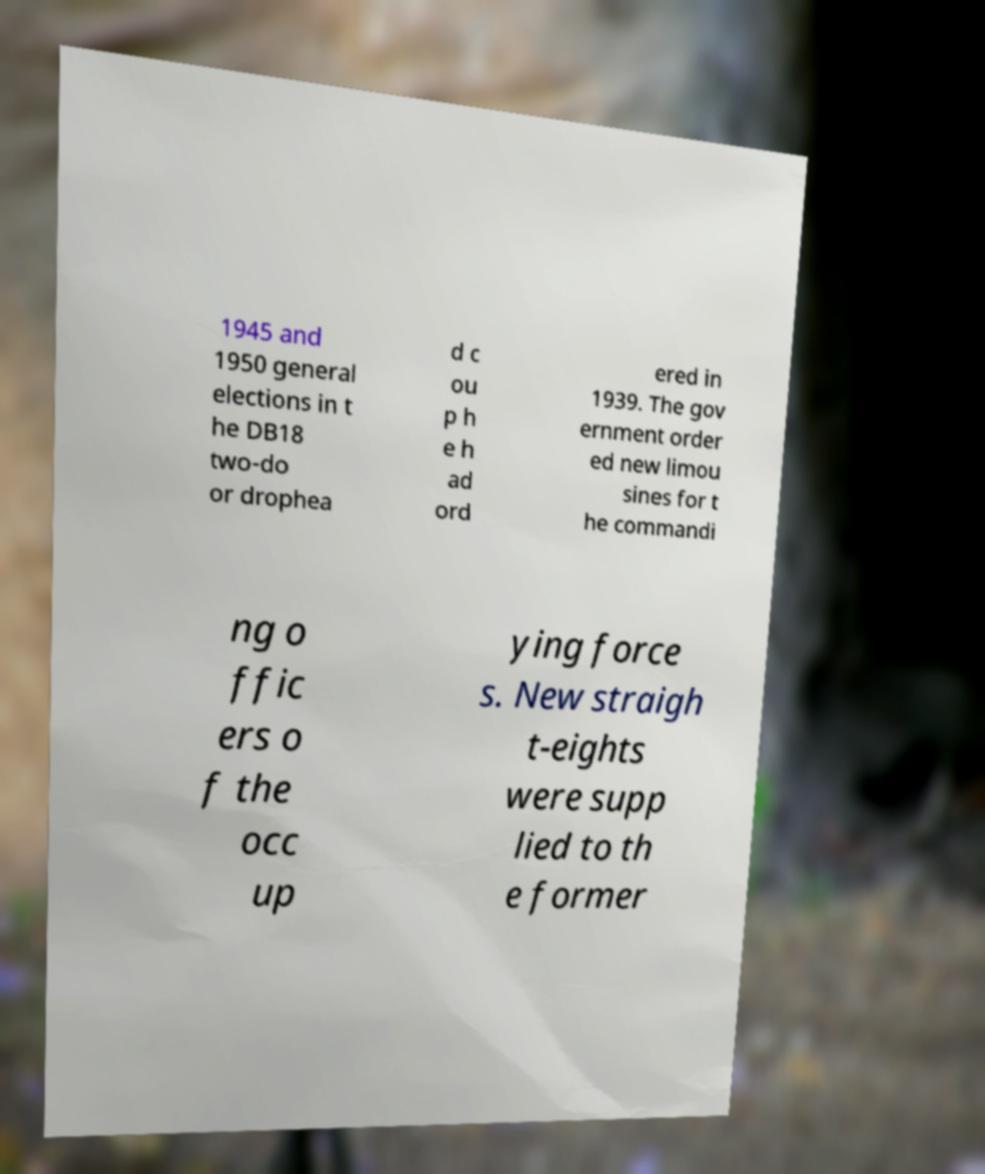Please read and relay the text visible in this image. What does it say? 1945 and 1950 general elections in t he DB18 two-do or drophea d c ou p h e h ad ord ered in 1939. The gov ernment order ed new limou sines for t he commandi ng o ffic ers o f the occ up ying force s. New straigh t-eights were supp lied to th e former 